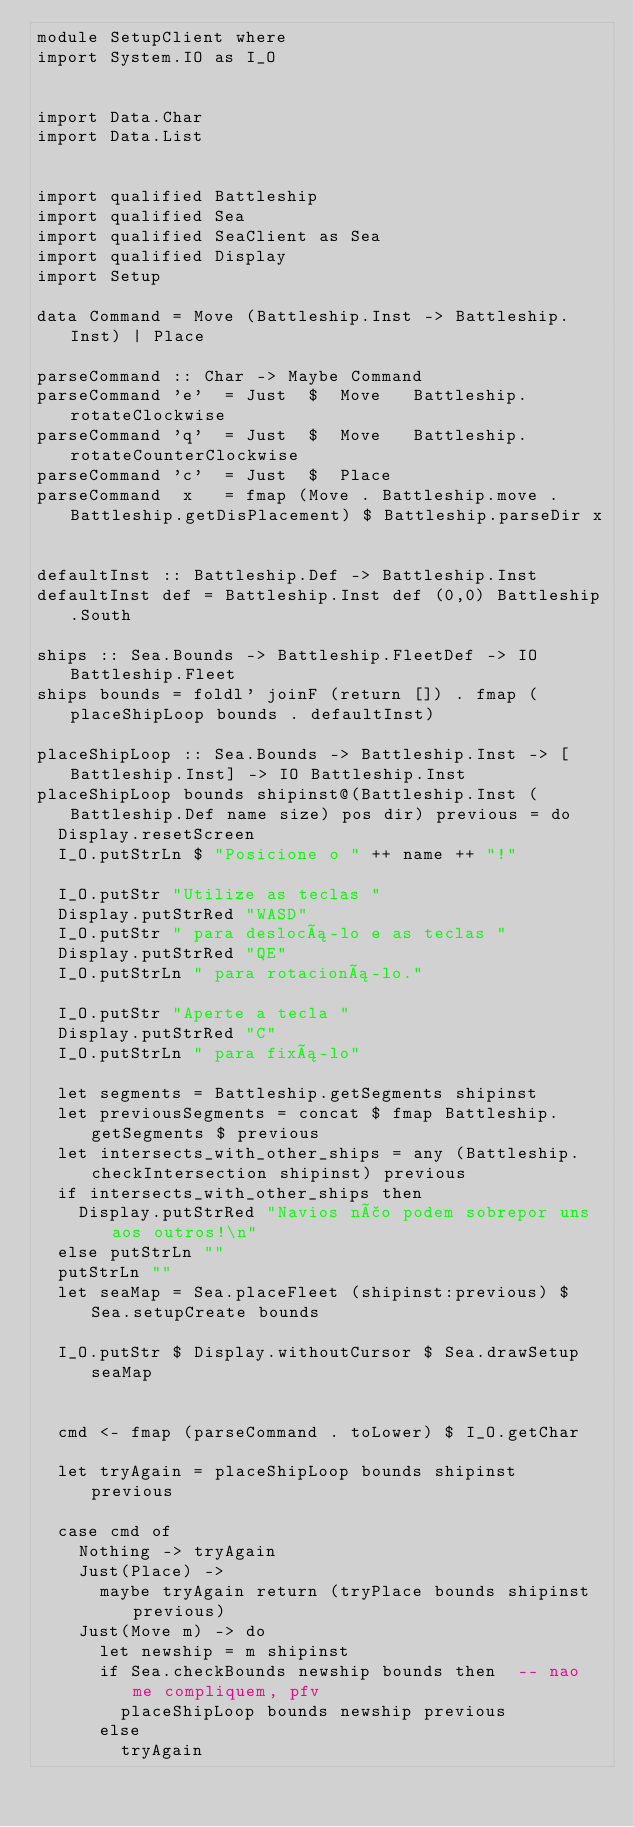Convert code to text. <code><loc_0><loc_0><loc_500><loc_500><_Haskell_>module SetupClient where
import System.IO as I_O


import Data.Char
import Data.List


import qualified Battleship
import qualified Sea
import qualified SeaClient as Sea
import qualified Display
import Setup

data Command = Move (Battleship.Inst -> Battleship.Inst) | Place

parseCommand :: Char -> Maybe Command
parseCommand 'e'  = Just  $  Move   Battleship.rotateClockwise
parseCommand 'q'  = Just  $  Move   Battleship.rotateCounterClockwise
parseCommand 'c'  = Just  $  Place
parseCommand  x   = fmap (Move . Battleship.move . Battleship.getDisPlacement) $ Battleship.parseDir x


defaultInst :: Battleship.Def -> Battleship.Inst
defaultInst def = Battleship.Inst def (0,0) Battleship.South

ships :: Sea.Bounds -> Battleship.FleetDef -> IO Battleship.Fleet
ships bounds = foldl' joinF (return []) . fmap (placeShipLoop bounds . defaultInst)

placeShipLoop :: Sea.Bounds -> Battleship.Inst -> [Battleship.Inst] -> IO Battleship.Inst
placeShipLoop bounds shipinst@(Battleship.Inst (Battleship.Def name size) pos dir) previous = do
  Display.resetScreen
  I_O.putStrLn $ "Posicione o " ++ name ++ "!"
  
  I_O.putStr "Utilize as teclas " 
  Display.putStrRed "WASD"
  I_O.putStr " para deslocá-lo e as teclas "
  Display.putStrRed "QE"
  I_O.putStrLn " para rotacioná-lo."
  
  I_O.putStr "Aperte a tecla "
  Display.putStrRed "C"
  I_O.putStrLn " para fixá-lo"
  
  let segments = Battleship.getSegments shipinst
  let previousSegments = concat $ fmap Battleship.getSegments $ previous
  let intersects_with_other_ships = any (Battleship.checkIntersection shipinst) previous
  if intersects_with_other_ships then
    Display.putStrRed "Navios não podem sobrepor uns aos outros!\n"
  else putStrLn ""
  putStrLn ""
  let seaMap = Sea.placeFleet (shipinst:previous) $ Sea.setupCreate bounds
  
  I_O.putStr $ Display.withoutCursor $ Sea.drawSetup seaMap
  
  
  cmd <- fmap (parseCommand . toLower) $ I_O.getChar 
  
  let tryAgain = placeShipLoop bounds shipinst previous
  
  case cmd of
    Nothing -> tryAgain
    Just(Place) ->
      maybe tryAgain return (tryPlace bounds shipinst previous)
    Just(Move m) -> do
      let newship = m shipinst
      if Sea.checkBounds newship bounds then  -- nao me compliquem, pfv
        placeShipLoop bounds newship previous
      else
        tryAgain

</code> 